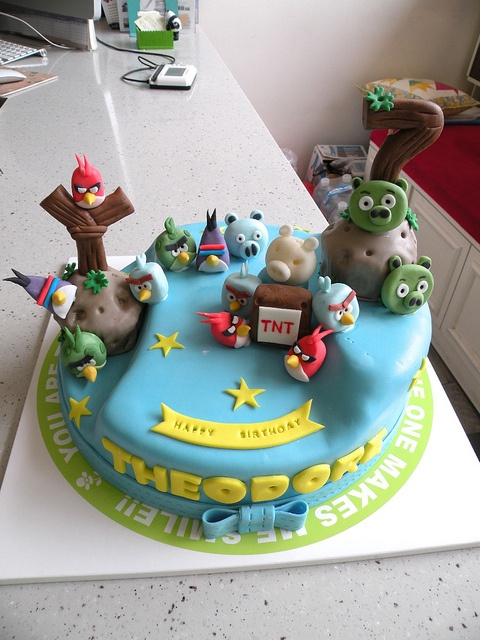Describe the objects in this image and their specific colors. I can see cake in black, gray, and teal tones, cell phone in black, white, darkgray, and gray tones, keyboard in black, darkgray, lightgray, gray, and lightblue tones, bottle in black, gray, darkgray, brown, and purple tones, and mouse in black, lavender, darkgray, and gray tones in this image. 